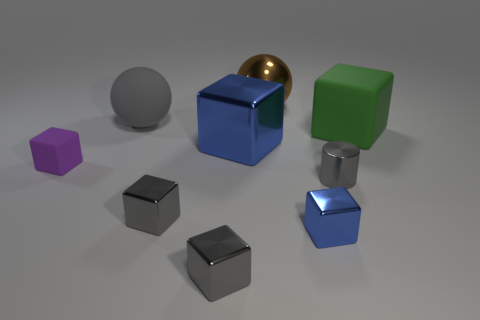Subtract all green cubes. How many cubes are left? 5 Subtract all green rubber cubes. How many cubes are left? 5 Subtract all purple cubes. Subtract all brown cylinders. How many cubes are left? 5 Subtract all cubes. How many objects are left? 3 Add 8 green rubber objects. How many green rubber objects exist? 9 Subtract 0 yellow spheres. How many objects are left? 9 Subtract all tiny purple blocks. Subtract all small yellow rubber cylinders. How many objects are left? 8 Add 7 big green things. How many big green things are left? 8 